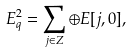Convert formula to latex. <formula><loc_0><loc_0><loc_500><loc_500>E _ { q } ^ { 2 } = \sum _ { j \in Z } \oplus E [ j , 0 ] ,</formula> 